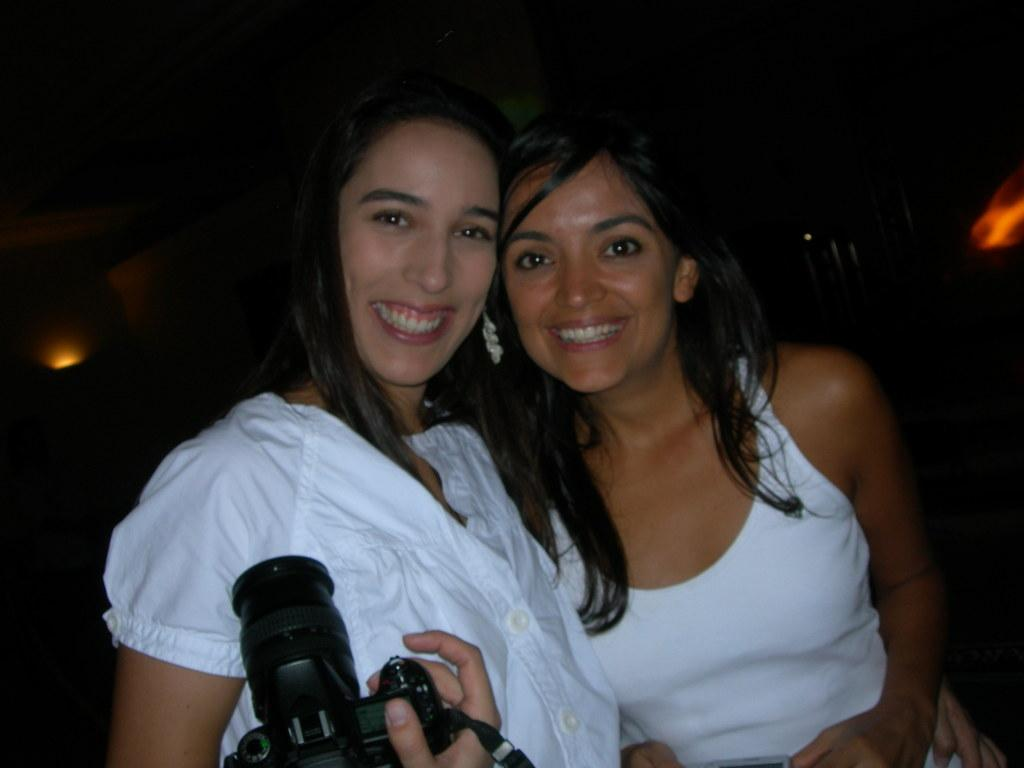How many people are in the image? There are two women in the image. What are the women doing in the image? The women are smiling in the image. What object is one of the women holding? One of the women is holding a camera. What can be seen in the background of the image? The background of the image is dark, and there are lights visible. What type of cork can be seen on the shoes of the women in the image? There is no mention of shoes or cork in the image, so we cannot determine if there are any corks on the shoes. Where is the park located in the image? There is no park present in the image; it features two women, one of whom is holding a camera. 